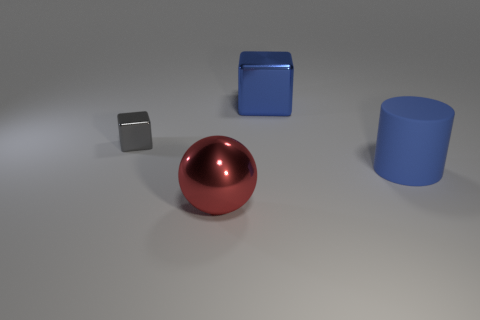There is a cube that is the same color as the matte cylinder; what is its material?
Your answer should be very brief. Metal. Are there any other things that have the same shape as the tiny shiny thing?
Make the answer very short. Yes. There is a blue object that is behind the gray thing; what is its material?
Provide a succinct answer. Metal. Is the block that is on the left side of the red object made of the same material as the blue cube?
Provide a short and direct response. Yes. What number of objects are either tiny yellow shiny cubes or blue things behind the gray thing?
Make the answer very short. 1. The other thing that is the same shape as the tiny gray object is what size?
Ensure brevity in your answer.  Large. Is there any other thing that has the same size as the gray cube?
Keep it short and to the point. No. Are there any large things in front of the gray cube?
Offer a terse response. Yes. There is a big metallic object in front of the blue rubber thing; is it the same color as the metal block that is in front of the big blue metal object?
Give a very brief answer. No. Is there a small purple metal thing that has the same shape as the big blue matte object?
Your answer should be compact. No. 